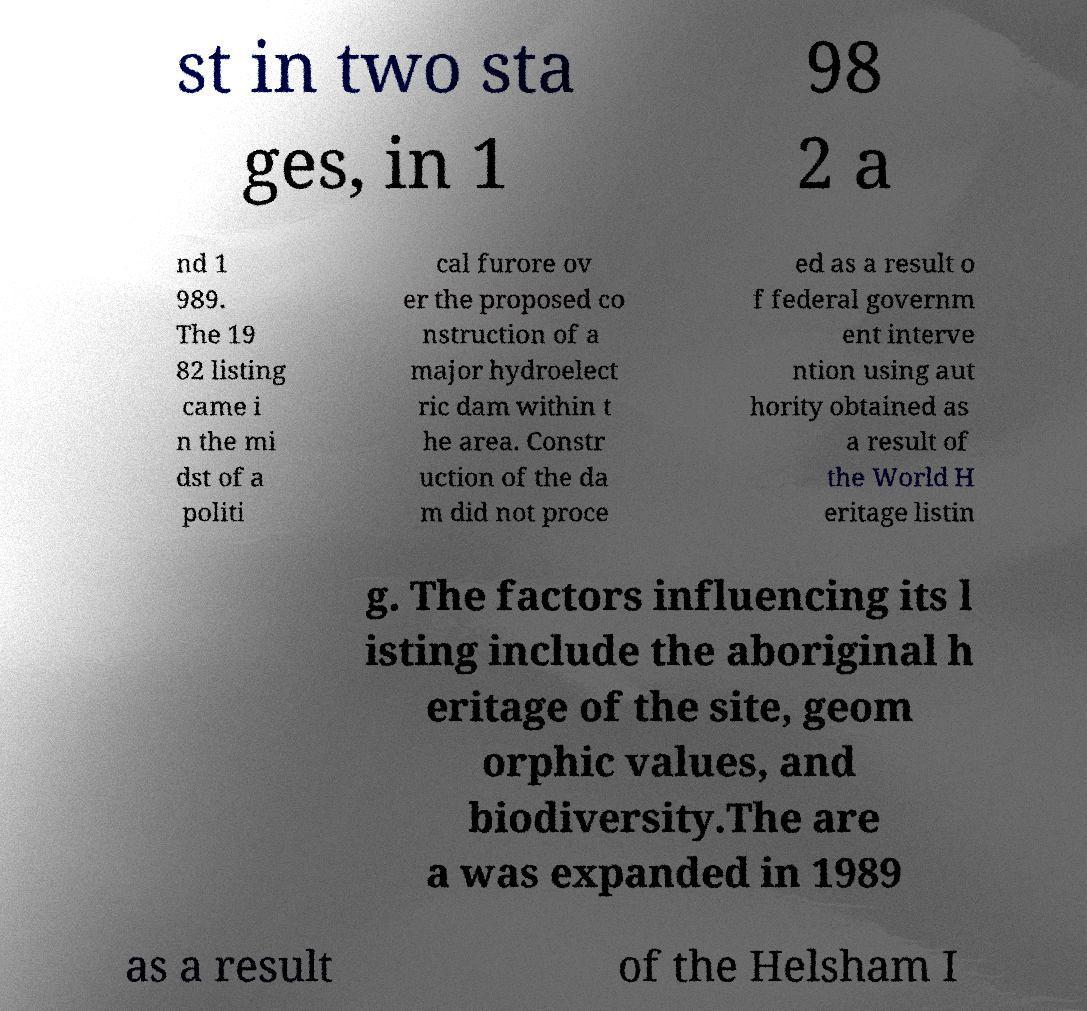Please identify and transcribe the text found in this image. st in two sta ges, in 1 98 2 a nd 1 989. The 19 82 listing came i n the mi dst of a politi cal furore ov er the proposed co nstruction of a major hydroelect ric dam within t he area. Constr uction of the da m did not proce ed as a result o f federal governm ent interve ntion using aut hority obtained as a result of the World H eritage listin g. The factors influencing its l isting include the aboriginal h eritage of the site, geom orphic values, and biodiversity.The are a was expanded in 1989 as a result of the Helsham I 